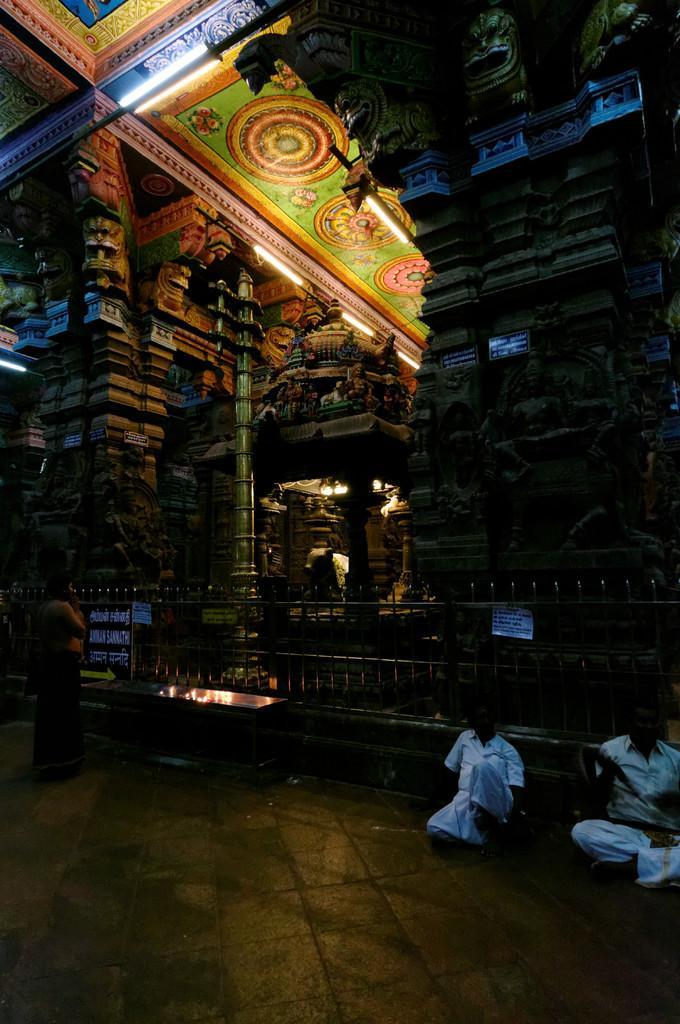Can you describe this image briefly? The image is taken in the temple. On the left side of the image we can see a man standing. At the bottom there are two people sitting and we can see a table. At the top there are lights. 